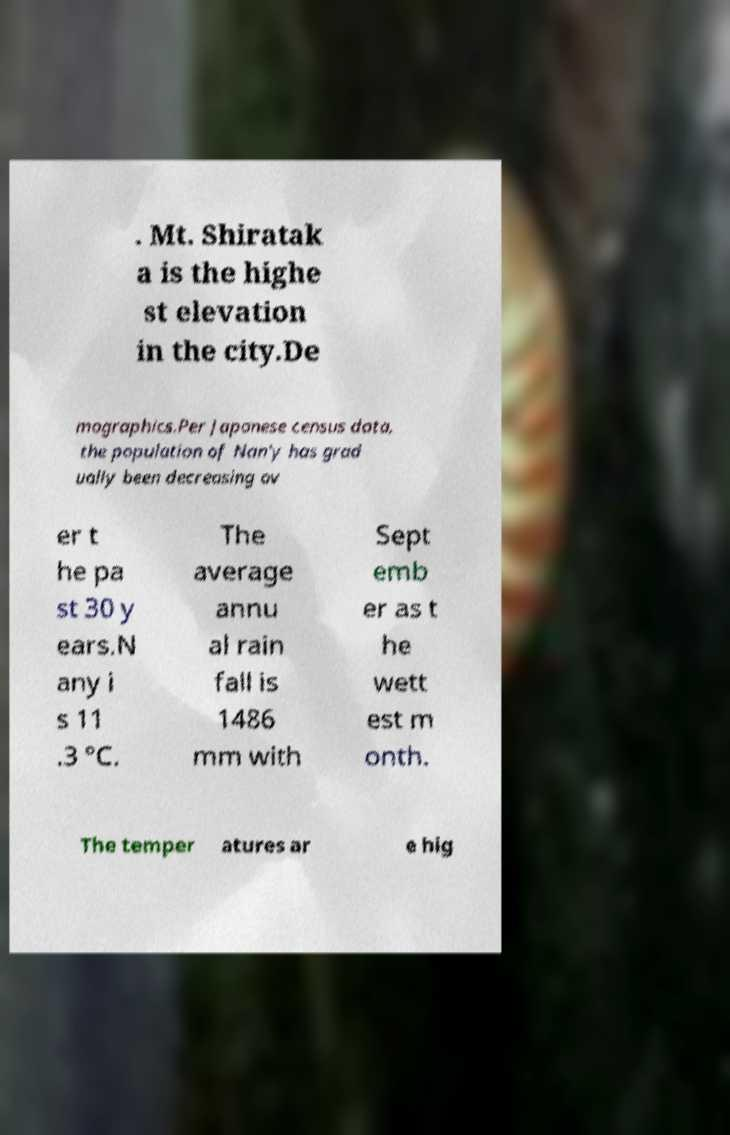Can you accurately transcribe the text from the provided image for me? . Mt. Shiratak a is the highe st elevation in the city.De mographics.Per Japanese census data, the population of Nan'y has grad ually been decreasing ov er t he pa st 30 y ears.N any i s 11 .3 °C. The average annu al rain fall is 1486 mm with Sept emb er as t he wett est m onth. The temper atures ar e hig 